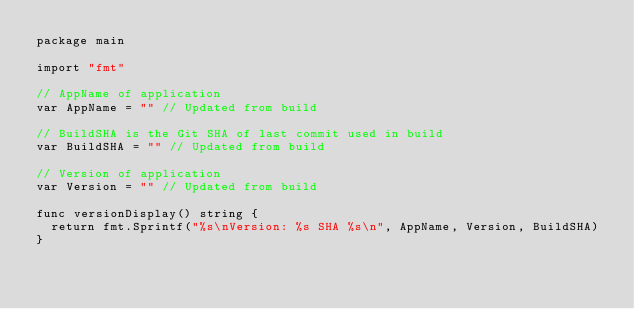Convert code to text. <code><loc_0><loc_0><loc_500><loc_500><_Go_>package main

import "fmt"

// AppName of application
var AppName = "" // Updated from build

// BuildSHA is the Git SHA of last commit used in build
var BuildSHA = "" // Updated from build

// Version of application
var Version = "" // Updated from build

func versionDisplay() string {
	return fmt.Sprintf("%s\nVersion: %s SHA %s\n", AppName, Version, BuildSHA)
}
</code> 